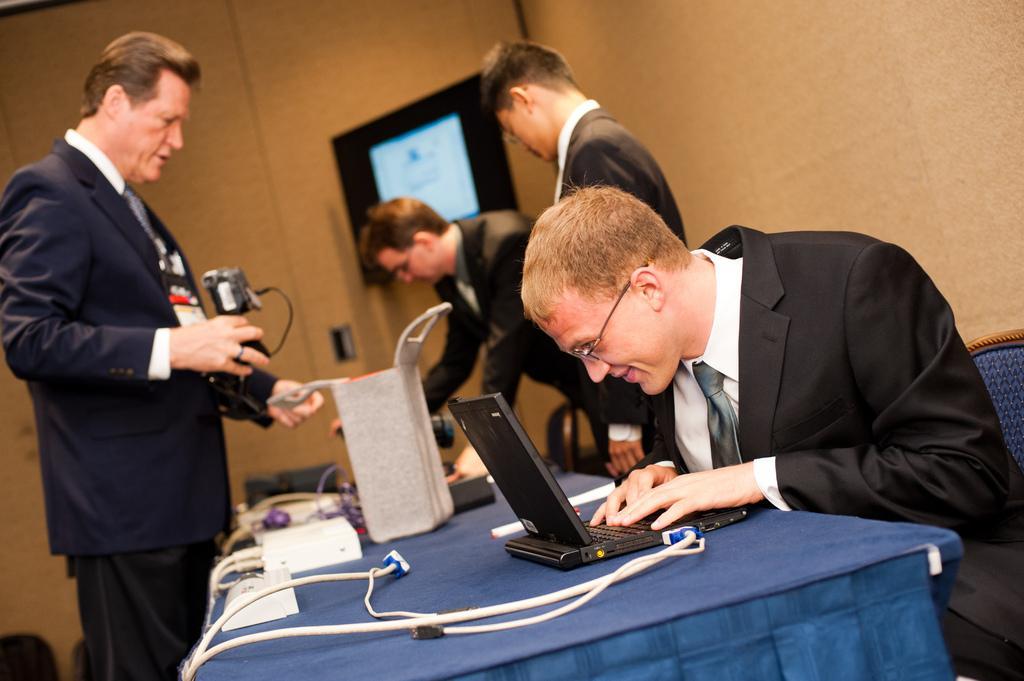In one or two sentences, can you explain what this image depicts? In the foreground of this image, on the table, there are cables, a laptop, marker, a bag like an object and few objects. Around the table, on a chair, there is a man sitting and in the background, there are men standing, a wall and a television. 